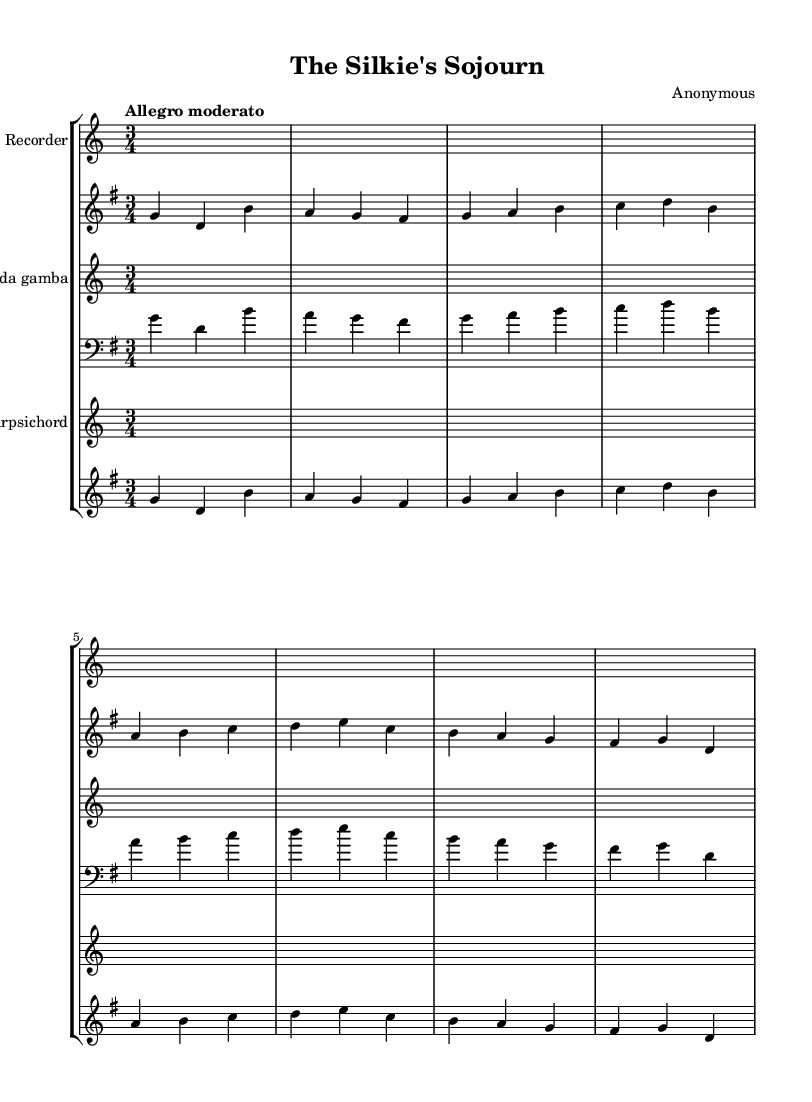What is the key signature of this piece? The key signature is G major, which has one sharp (F#). This can be identified by looking at the key signature indicated at the beginning of the staff.
Answer: G major What is the time signature of this music? The time signature is 3/4, which can be seen at the beginning of the score. This means there are three beats in a measure, and a quarter note gets one beat.
Answer: 3/4 What is the tempo marking for the music? The tempo marking is "Allegro moderato." This can be found written above the staff, indicating the speed at which the piece should be played.
Answer: Allegro moderato How many measures are in the allemande section? The allemande has four measures, which can be counted by looking at the grouping of the notes and the bar lines.
Answer: 4 Identify the instruments in the score. The instruments listed are Recorder, Viola da gamba, and Harpsichord. These are specified at the start of each staff in the score.
Answer: Recorder, Viola da gamba, Harpsichord What musical form does the allemande likely follow in Baroque suites? The allemande typically follows a binary form (AABB). In Baroque music, this means the first section is played followed by a repeat of that section and then a second section that is also repeated.
Answer: Binary form (AABB) 